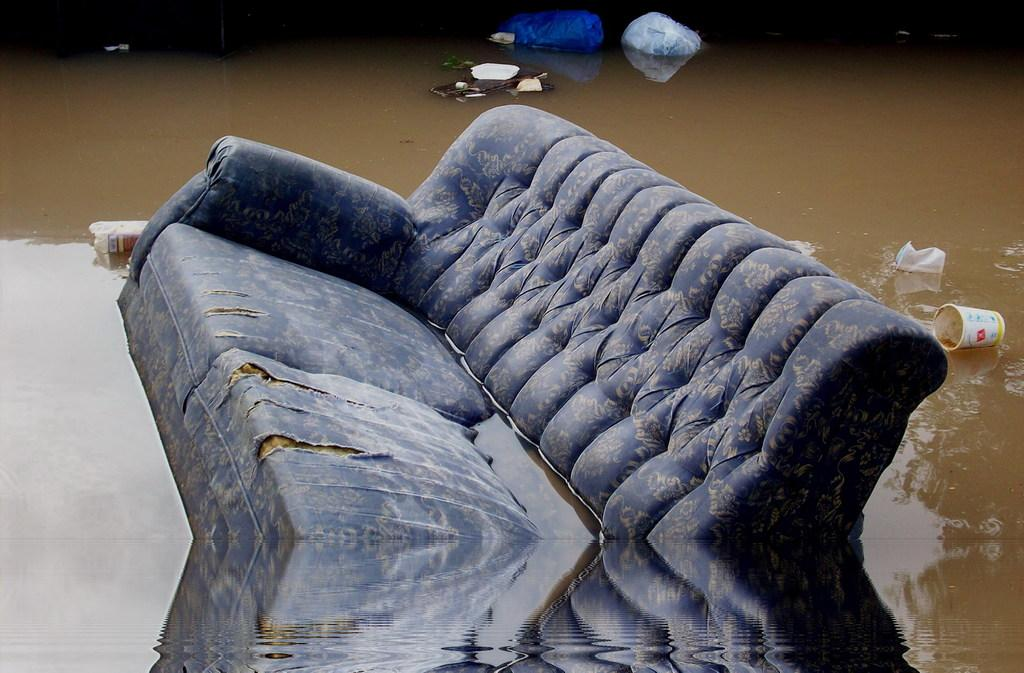What piece of furniture is in the water in the image? There is a sofa in the water in the image. What can be seen in the background of the image? In the background, there are plastic covers, a bottle, and a cup. What is the rate at which the rabbits are shaking in the image? There are no rabbits present in the image, so it is not possible to determine their rate of shaking. 